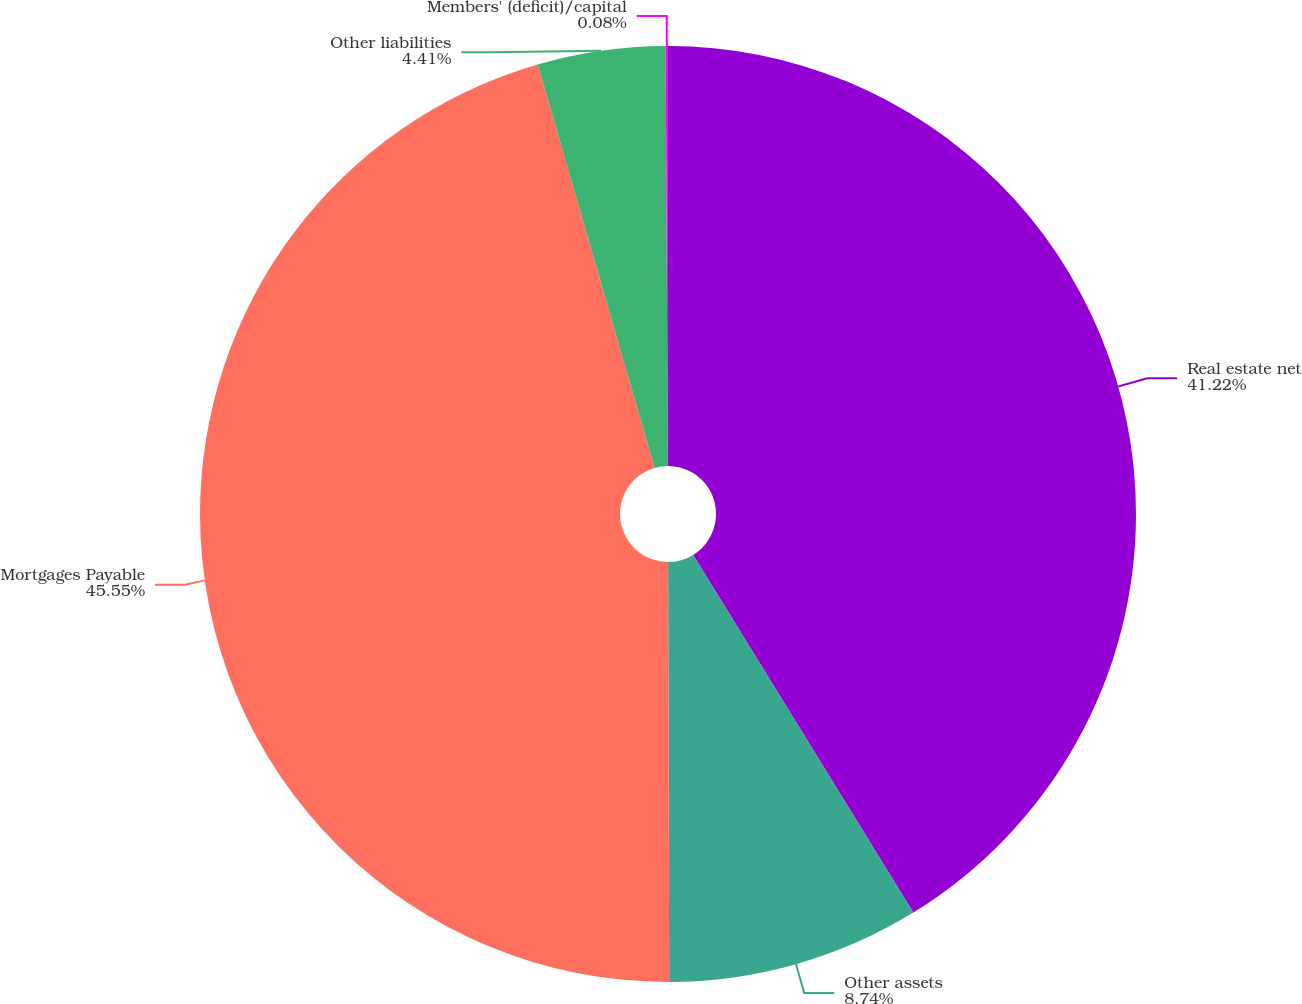<chart> <loc_0><loc_0><loc_500><loc_500><pie_chart><fcel>Real estate net<fcel>Other assets<fcel>Mortgages Payable<fcel>Other liabilities<fcel>Members' (deficit)/capital<nl><fcel>41.22%<fcel>8.74%<fcel>45.55%<fcel>4.41%<fcel>0.08%<nl></chart> 